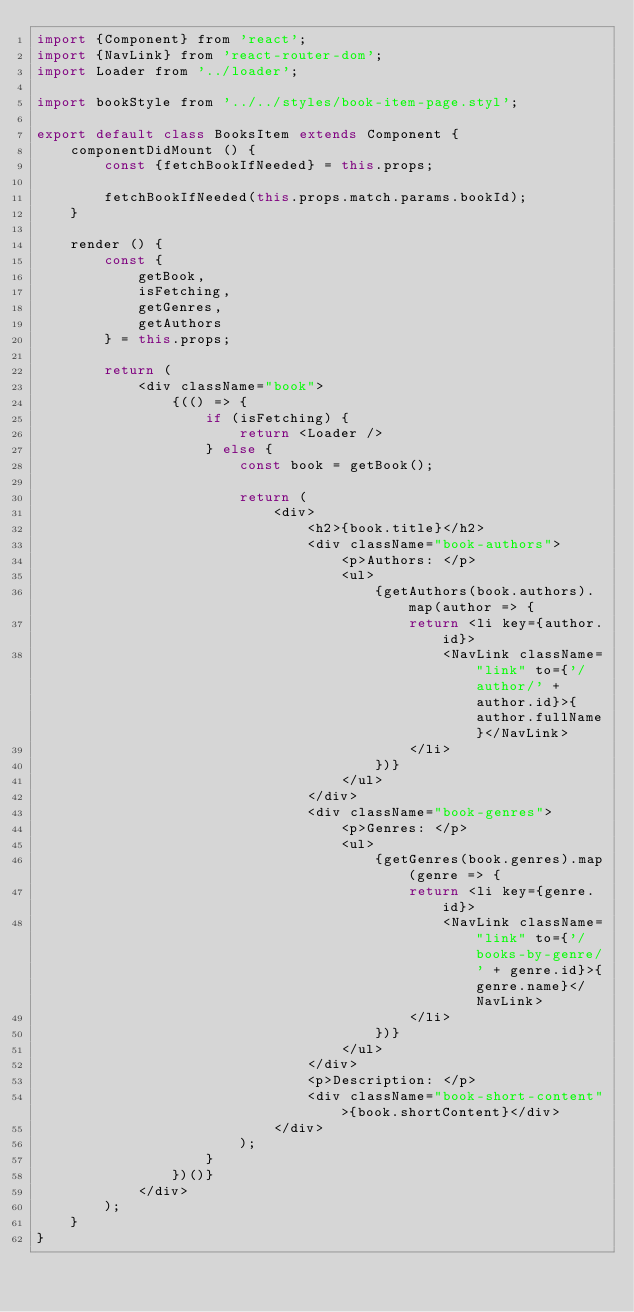Convert code to text. <code><loc_0><loc_0><loc_500><loc_500><_JavaScript_>import {Component} from 'react';
import {NavLink} from 'react-router-dom';
import Loader from '../loader';

import bookStyle from '../../styles/book-item-page.styl';

export default class BooksItem extends Component {
    componentDidMount () {
        const {fetchBookIfNeeded} = this.props;

        fetchBookIfNeeded(this.props.match.params.bookId);
    }

    render () {
        const {
            getBook,
            isFetching,
            getGenres,
            getAuthors
        } = this.props;

        return (
            <div className="book">
                {(() => {
                    if (isFetching) {
                        return <Loader />
                    } else {
                        const book = getBook();

                        return (
                            <div>
                                <h2>{book.title}</h2>
                                <div className="book-authors">
                                    <p>Authors: </p>
                                    <ul>
                                        {getAuthors(book.authors).map(author => {
                                            return <li key={author.id}>
                                                <NavLink className="link" to={'/author/' + author.id}>{author.fullName}</NavLink>
                                            </li>
                                        })}
                                    </ul>
                                </div>
                                <div className="book-genres">
                                    <p>Genres: </p>
                                    <ul>
                                        {getGenres(book.genres).map(genre => {
                                            return <li key={genre.id}>
                                                <NavLink className="link" to={'/books-by-genre/' + genre.id}>{genre.name}</NavLink>
                                            </li>
                                        })}
                                    </ul>
                                </div>
                                <p>Description: </p>
                                <div className="book-short-content">{book.shortContent}</div>
                            </div>
                        );
                    }
                })()}
            </div>
        );
    }
}</code> 